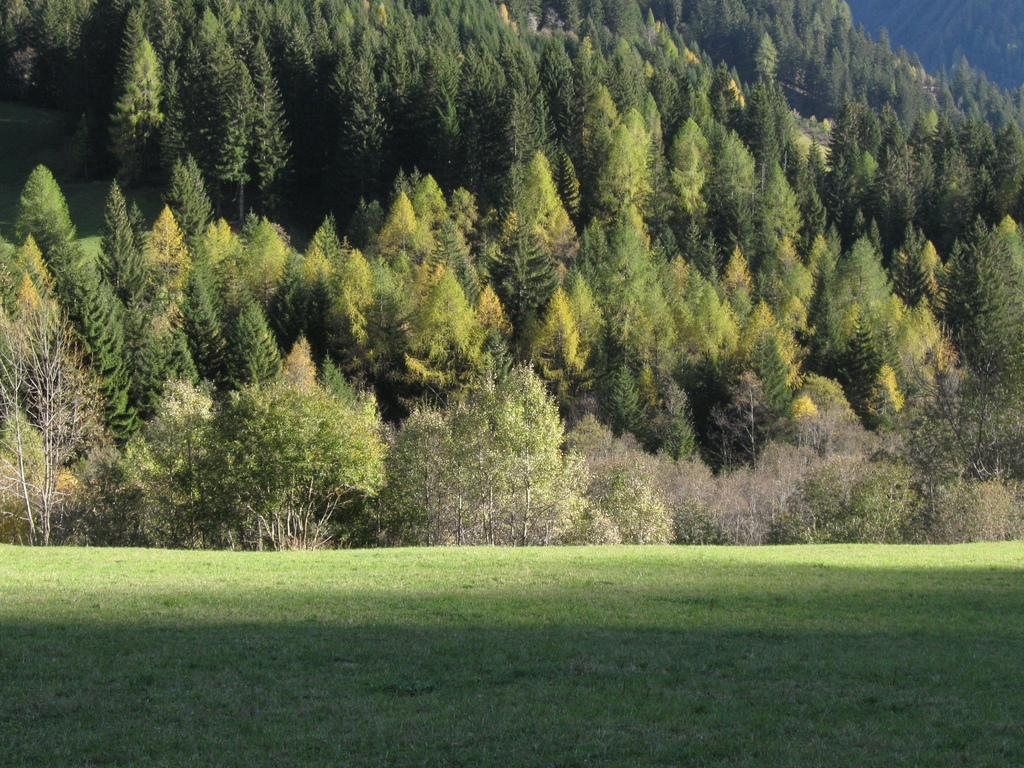What type of vegetation is at the bottom of the image? There is grass at the bottom of the image. What can be seen in the background of the image? There are trees and plants in the background of the image. What flavor of popcorn is being served behind the curtain in the image? There is no popcorn or curtain present in the image. 